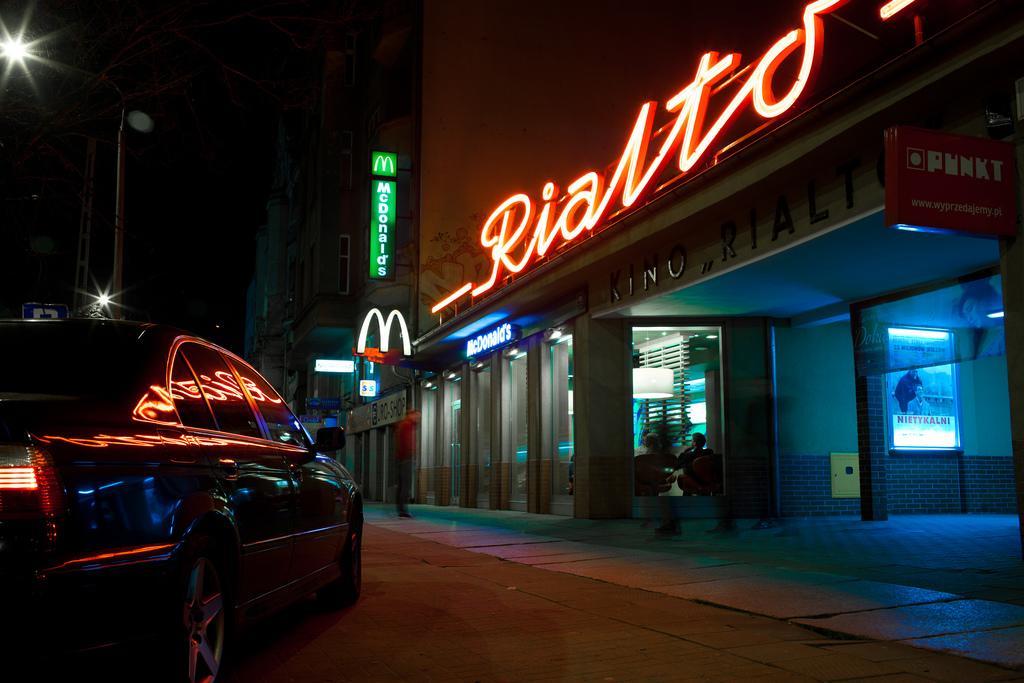How would you summarize this image in a sentence or two? In the foreground of this image, on the left, there is a car on the road. On the right, there are buildings with name boards and the lights. In the background, there are two lights, poles, a board and the dark sky. 